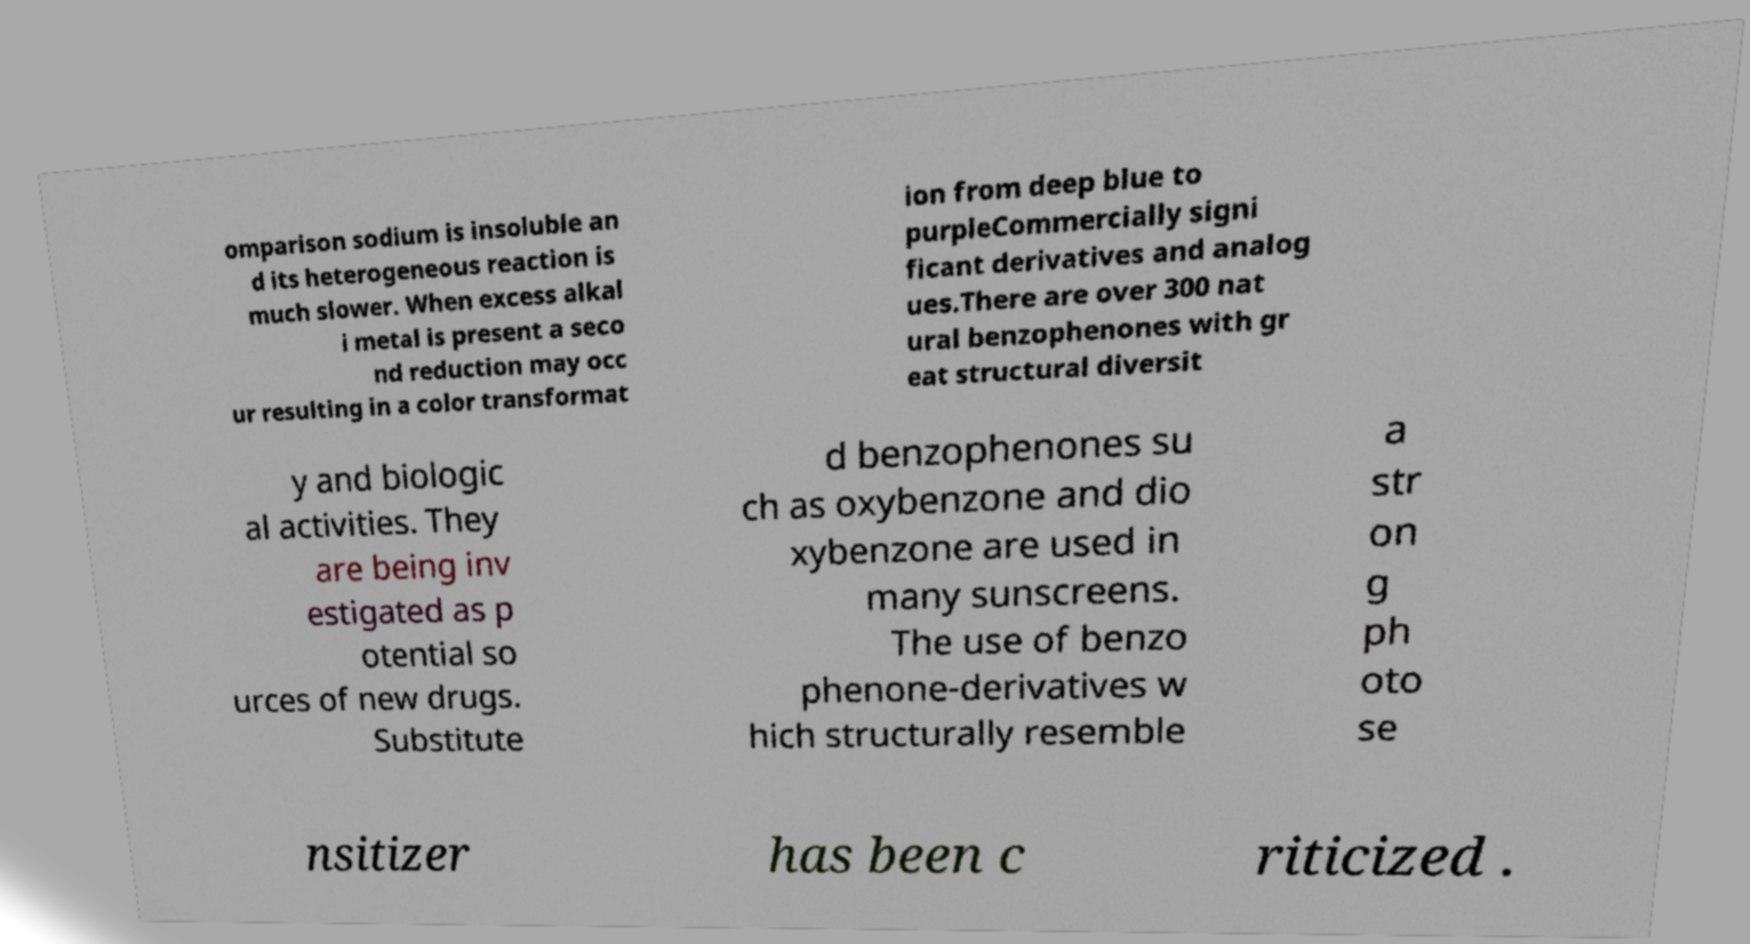For documentation purposes, I need the text within this image transcribed. Could you provide that? omparison sodium is insoluble an d its heterogeneous reaction is much slower. When excess alkal i metal is present a seco nd reduction may occ ur resulting in a color transformat ion from deep blue to purpleCommercially signi ficant derivatives and analog ues.There are over 300 nat ural benzophenones with gr eat structural diversit y and biologic al activities. They are being inv estigated as p otential so urces of new drugs. Substitute d benzophenones su ch as oxybenzone and dio xybenzone are used in many sunscreens. The use of benzo phenone-derivatives w hich structurally resemble a str on g ph oto se nsitizer has been c riticized . 